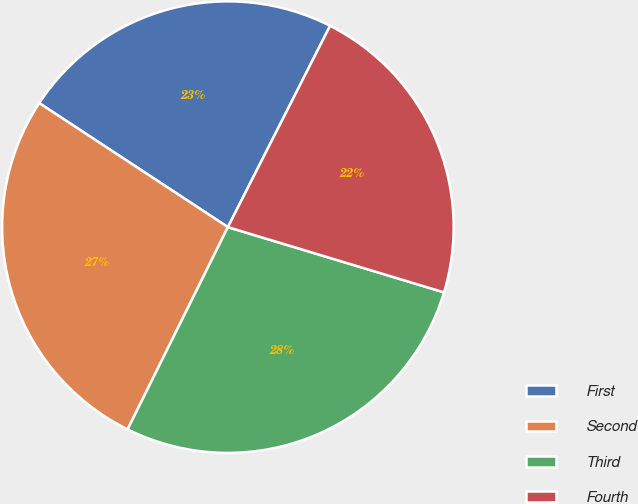<chart> <loc_0><loc_0><loc_500><loc_500><pie_chart><fcel>First<fcel>Second<fcel>Third<fcel>Fourth<nl><fcel>23.22%<fcel>26.93%<fcel>27.66%<fcel>22.19%<nl></chart> 